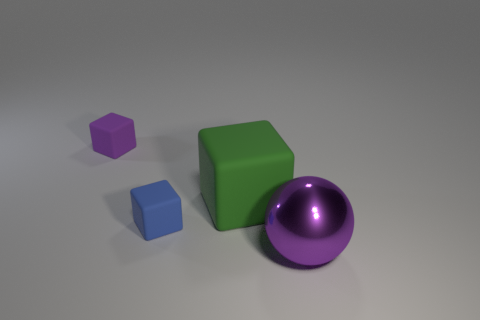Is there another thing of the same color as the large metallic thing?
Offer a very short reply. Yes. Is the green matte thing the same size as the shiny thing?
Your response must be concise. Yes. What is the material of the purple thing right of the large object that is behind the purple metal object?
Make the answer very short. Metal. There is a purple object on the left side of the purple metallic object; does it have the same size as the big rubber thing?
Offer a terse response. No. How many rubber things are large gray balls or tiny blue objects?
Your response must be concise. 1. The thing that is right of the tiny blue matte object and in front of the green matte block is made of what material?
Make the answer very short. Metal. Are the green object and the tiny blue cube made of the same material?
Give a very brief answer. Yes. What size is the thing that is to the right of the tiny blue rubber block and left of the purple metallic object?
Make the answer very short. Large. The big green object has what shape?
Keep it short and to the point. Cube. What number of objects are green cubes or blocks that are on the right side of the small blue matte thing?
Give a very brief answer. 1. 